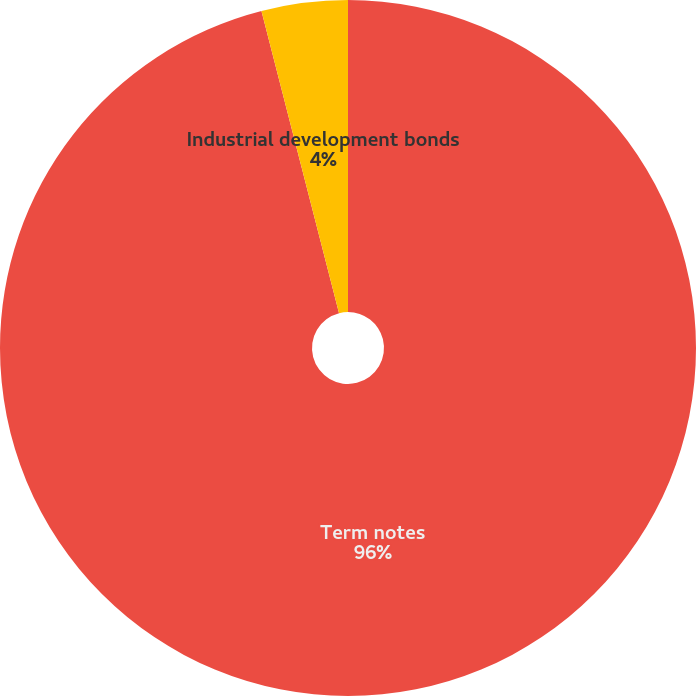Convert chart to OTSL. <chart><loc_0><loc_0><loc_500><loc_500><pie_chart><fcel>Term notes<fcel>Industrial development bonds<nl><fcel>96.0%<fcel>4.0%<nl></chart> 